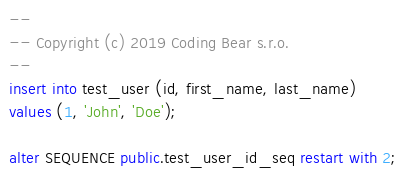<code> <loc_0><loc_0><loc_500><loc_500><_SQL_>--
-- Copyright (c) 2019 Coding Bear s.r.o.
--
insert into test_user (id, first_name, last_name)
values (1, 'John', 'Doe');

alter SEQUENCE public.test_user_id_seq restart with 2;
</code> 